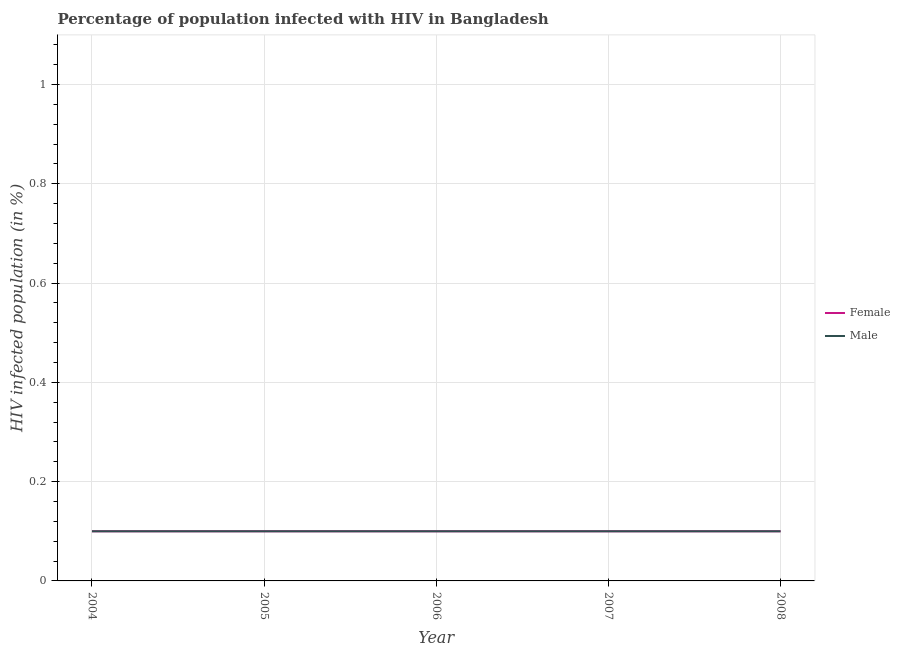How many different coloured lines are there?
Ensure brevity in your answer.  2. Does the line corresponding to percentage of females who are infected with hiv intersect with the line corresponding to percentage of males who are infected with hiv?
Give a very brief answer. Yes. Is the number of lines equal to the number of legend labels?
Your answer should be compact. Yes. Across all years, what is the maximum percentage of males who are infected with hiv?
Give a very brief answer. 0.1. What is the difference between the percentage of males who are infected with hiv in 2007 and that in 2008?
Provide a short and direct response. 0. What is the average percentage of males who are infected with hiv per year?
Offer a very short reply. 0.1. In the year 2005, what is the difference between the percentage of females who are infected with hiv and percentage of males who are infected with hiv?
Provide a succinct answer. 0. What is the ratio of the percentage of males who are infected with hiv in 2006 to that in 2007?
Provide a short and direct response. 1. Is the difference between the percentage of males who are infected with hiv in 2006 and 2008 greater than the difference between the percentage of females who are infected with hiv in 2006 and 2008?
Provide a short and direct response. No. What is the difference between the highest and the lowest percentage of females who are infected with hiv?
Provide a succinct answer. 0. In how many years, is the percentage of females who are infected with hiv greater than the average percentage of females who are infected with hiv taken over all years?
Give a very brief answer. 0. Does the percentage of males who are infected with hiv monotonically increase over the years?
Give a very brief answer. No. Is the percentage of females who are infected with hiv strictly greater than the percentage of males who are infected with hiv over the years?
Give a very brief answer. No. Is the percentage of females who are infected with hiv strictly less than the percentage of males who are infected with hiv over the years?
Give a very brief answer. No. How many years are there in the graph?
Make the answer very short. 5. Are the values on the major ticks of Y-axis written in scientific E-notation?
Offer a very short reply. No. Does the graph contain any zero values?
Provide a short and direct response. No. How many legend labels are there?
Make the answer very short. 2. What is the title of the graph?
Keep it short and to the point. Percentage of population infected with HIV in Bangladesh. What is the label or title of the X-axis?
Offer a terse response. Year. What is the label or title of the Y-axis?
Offer a very short reply. HIV infected population (in %). What is the HIV infected population (in %) of Female in 2004?
Offer a very short reply. 0.1. What is the HIV infected population (in %) in Male in 2004?
Provide a short and direct response. 0.1. What is the HIV infected population (in %) in Female in 2005?
Give a very brief answer. 0.1. What is the HIV infected population (in %) in Female in 2007?
Your answer should be compact. 0.1. What is the HIV infected population (in %) in Male in 2007?
Provide a short and direct response. 0.1. What is the HIV infected population (in %) of Female in 2008?
Ensure brevity in your answer.  0.1. What is the HIV infected population (in %) in Male in 2008?
Make the answer very short. 0.1. Across all years, what is the minimum HIV infected population (in %) of Female?
Your answer should be compact. 0.1. What is the difference between the HIV infected population (in %) in Female in 2004 and that in 2005?
Your response must be concise. 0. What is the difference between the HIV infected population (in %) of Female in 2004 and that in 2006?
Ensure brevity in your answer.  0. What is the difference between the HIV infected population (in %) of Female in 2005 and that in 2006?
Keep it short and to the point. 0. What is the difference between the HIV infected population (in %) in Female in 2005 and that in 2007?
Provide a short and direct response. 0. What is the difference between the HIV infected population (in %) in Male in 2005 and that in 2008?
Offer a terse response. 0. What is the difference between the HIV infected population (in %) of Male in 2006 and that in 2007?
Keep it short and to the point. 0. What is the difference between the HIV infected population (in %) in Female in 2006 and that in 2008?
Provide a succinct answer. 0. What is the difference between the HIV infected population (in %) of Male in 2006 and that in 2008?
Ensure brevity in your answer.  0. What is the difference between the HIV infected population (in %) in Female in 2007 and that in 2008?
Ensure brevity in your answer.  0. What is the difference between the HIV infected population (in %) of Female in 2004 and the HIV infected population (in %) of Male in 2005?
Give a very brief answer. 0. What is the difference between the HIV infected population (in %) in Female in 2004 and the HIV infected population (in %) in Male in 2006?
Provide a short and direct response. 0. What is the difference between the HIV infected population (in %) of Female in 2005 and the HIV infected population (in %) of Male in 2007?
Offer a very short reply. 0. What is the difference between the HIV infected population (in %) in Female in 2006 and the HIV infected population (in %) in Male in 2007?
Provide a short and direct response. 0. What is the difference between the HIV infected population (in %) in Female in 2006 and the HIV infected population (in %) in Male in 2008?
Ensure brevity in your answer.  0. In the year 2004, what is the difference between the HIV infected population (in %) of Female and HIV infected population (in %) of Male?
Your response must be concise. 0. In the year 2005, what is the difference between the HIV infected population (in %) in Female and HIV infected population (in %) in Male?
Offer a very short reply. 0. What is the ratio of the HIV infected population (in %) in Male in 2004 to that in 2005?
Your answer should be very brief. 1. What is the ratio of the HIV infected population (in %) of Female in 2004 to that in 2006?
Your answer should be very brief. 1. What is the ratio of the HIV infected population (in %) in Male in 2004 to that in 2006?
Offer a very short reply. 1. What is the ratio of the HIV infected population (in %) of Male in 2004 to that in 2007?
Give a very brief answer. 1. What is the ratio of the HIV infected population (in %) of Male in 2004 to that in 2008?
Give a very brief answer. 1. What is the ratio of the HIV infected population (in %) in Female in 2005 to that in 2006?
Your response must be concise. 1. What is the ratio of the HIV infected population (in %) in Male in 2005 to that in 2006?
Offer a terse response. 1. What is the ratio of the HIV infected population (in %) in Female in 2005 to that in 2007?
Keep it short and to the point. 1. What is the ratio of the HIV infected population (in %) of Male in 2006 to that in 2007?
Ensure brevity in your answer.  1. What is the ratio of the HIV infected population (in %) in Female in 2006 to that in 2008?
Provide a succinct answer. 1. What is the ratio of the HIV infected population (in %) of Male in 2007 to that in 2008?
Your answer should be very brief. 1. What is the difference between the highest and the second highest HIV infected population (in %) of Male?
Offer a terse response. 0. 